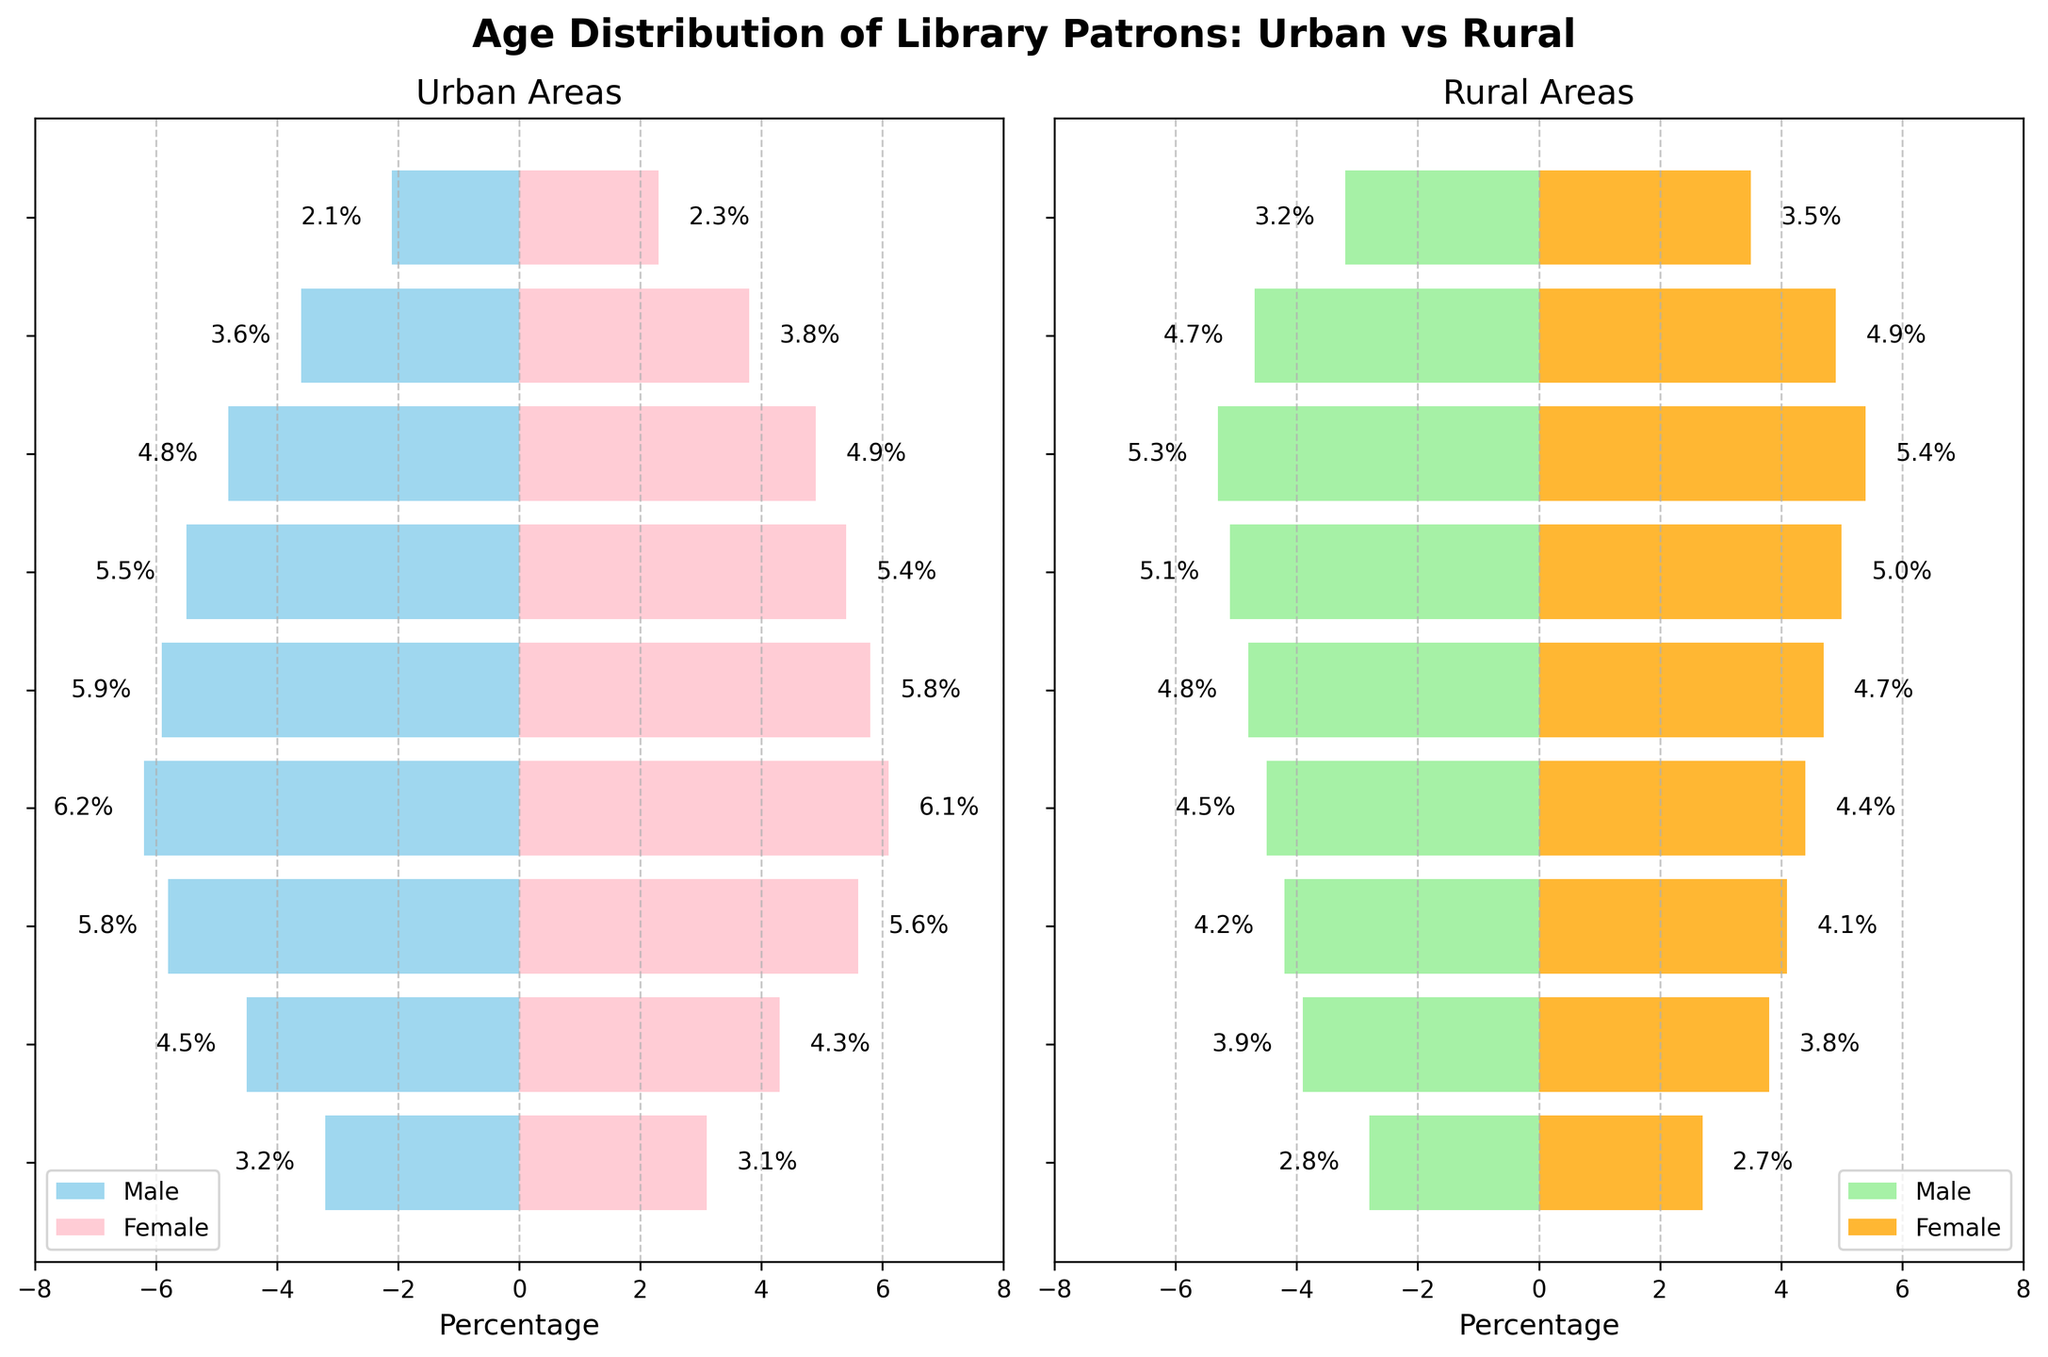What's the title of the figure? The title is located at the top of the figure in a larger and bold font.
Answer: Age Distribution of Library Patrons: Urban vs. Rural What age group has the highest percentage of rural female patrons? Look at the rural females' side of the figure and find the bar with the largest value. The highest percentage bar is for the age group 60-69.
Answer: 60-69 Which area has a higher percentage of patrons in the 20-29 age group, urban or rural? Compare the length of the bars for the 20-29 age group for both areas. The urban side has higher percentages for both males and females.
Answer: Urban What is the combined percentage of rural male and female patrons in the 70-79 age group? Add the percentages of rural male and female patrons in the 70-79 age group together: 4.7 (male) + 4.9 (female).
Answer: 9.6% Which gender in urban areas has a higher percentage of patrons in the age group 0-9? Compare the length of the bars for both males and females in the urban side for the age group 0-9. The female bar is slightly shorter.
Answer: Male How does the percentage of urban patrons in the 50-59 age group compare to the rural patrons in the same group? Compare the sum of urban male and female patrons (5.5 + 5.4) to that of rural male and female patrons (5.1 + 5.0). Urban total is 10.9% and rural total is 10.1%, so urban is higher.
Answer: Urban has higher percentage What age group has the smallest percentage of male patrons in urban areas? For the urban males’ bars, find the smallest bar. The smallest percentage is in the age group 80+.
Answer: 80+ Are there more rural male or rural female patrons in the 40-49 age group? Compare the lengths of the bars for rural males and rural females in the 40-49 age group. The female bar is shorter.
Answer: Male Which area has the larger disparity between male and female patrons in the 60-69 age group? Assess the difference in lengths between the male and female bars for both urban and rural areas in the 60-69 age group. The rural area shows a closer match between the male and female bars, whereas urban has a similar percentage.
Answer: Urban What is the median age group of urban female patrons based on their distribution? Determine the median age by finding the middle age group for urban female patrons. There are nine age groups, and the median is approximately the 30-39 age group as it is the fifth group.
Answer: 30-39 